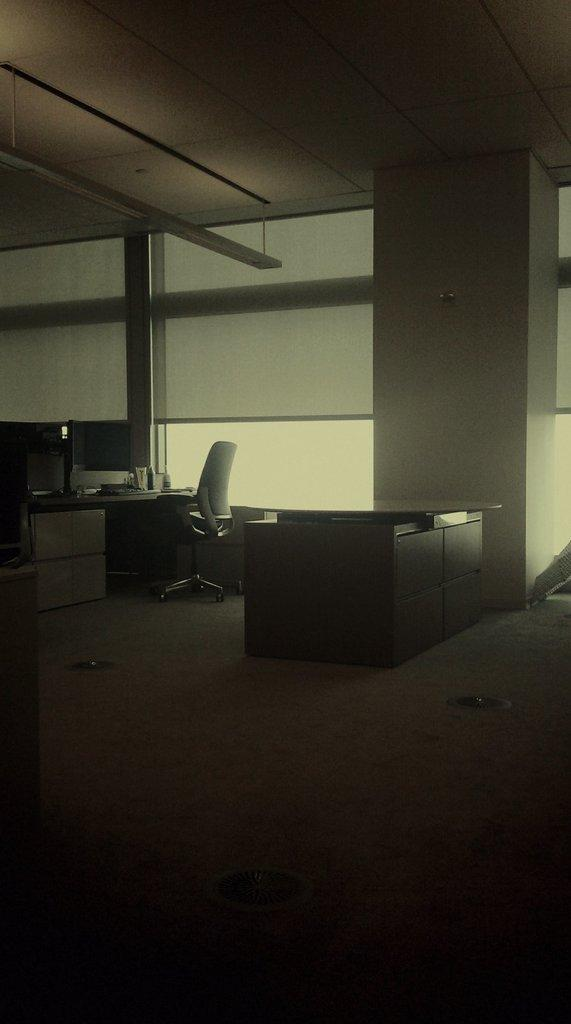What type of setting is depicted in the image? The image is taken in an office. What is the primary surface visible in the image? There is a floor in the image. What type of furniture is present on the floor? There are tables and chairs on the floor. What can be seen behind the chairs in the image? The background of the chair is a glass window, and there is also a wall in the background. What is the rate of the afternoon sun shining through the window in the image? The image does not provide information about the time of day or the intensity of sunlight, so it is not possible to determine the rate of the afternoon sun. 